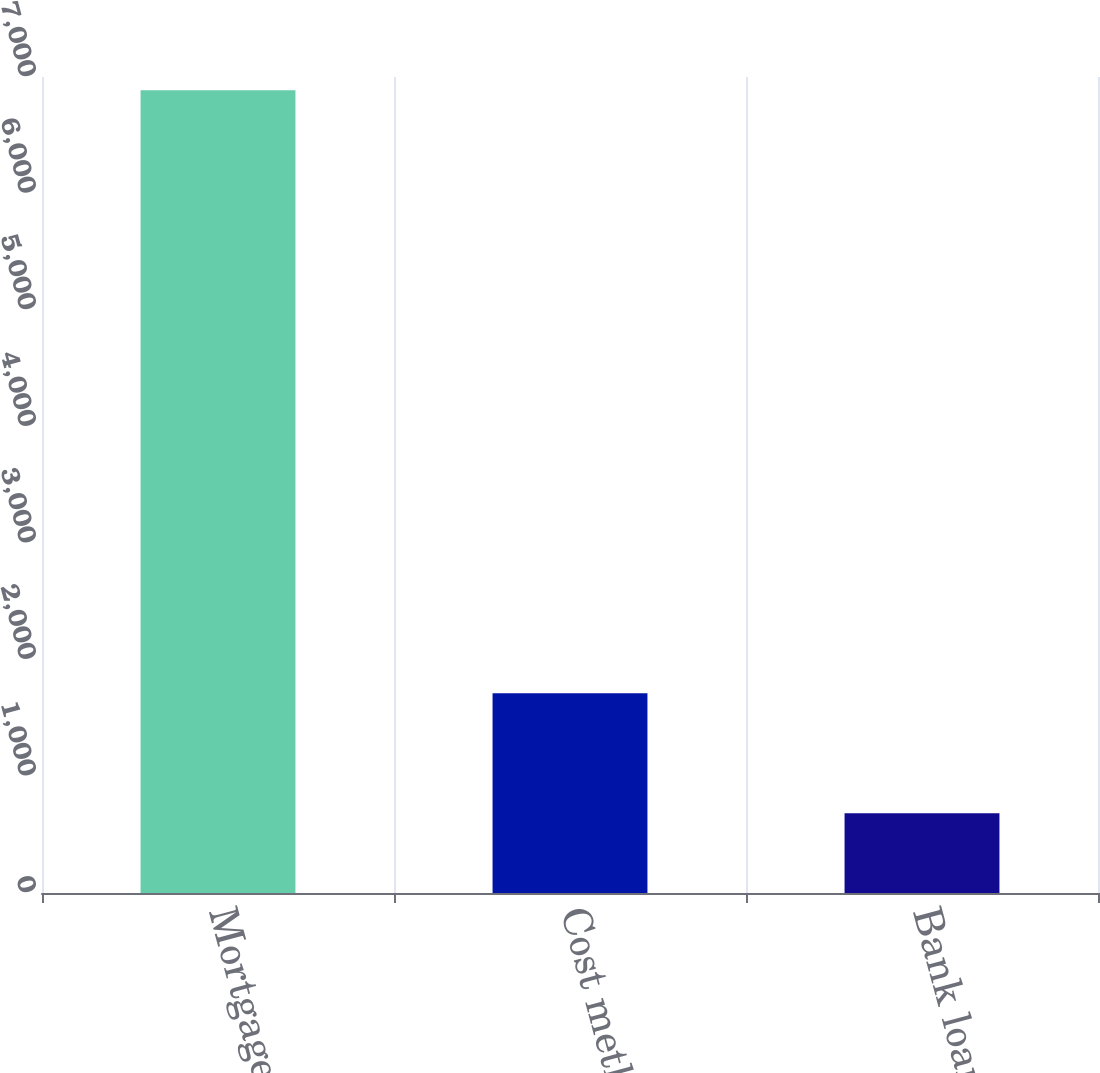Convert chart to OTSL. <chart><loc_0><loc_0><loc_500><loc_500><bar_chart><fcel>Mortgage loans<fcel>Cost method limited<fcel>Bank loans<nl><fcel>6886<fcel>1714<fcel>684<nl></chart> 